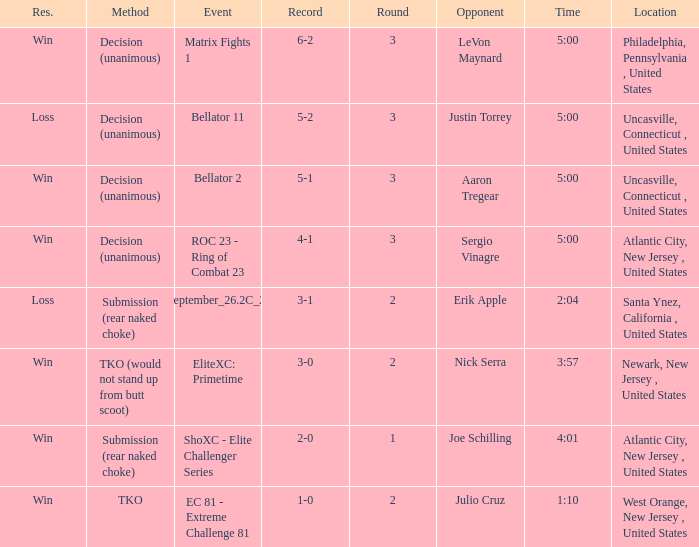What was the round that Sergio Vinagre had a time of 5:00? 3.0. 